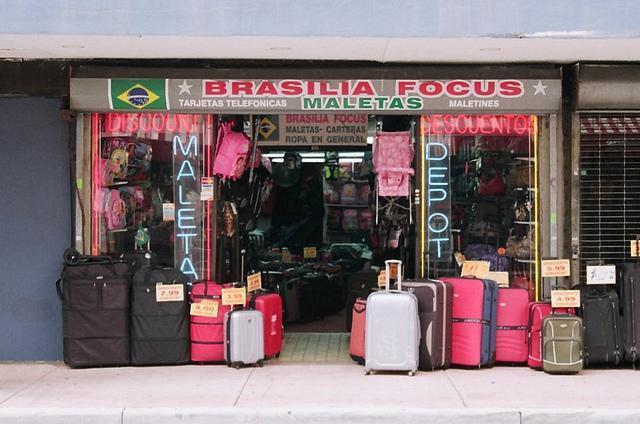How many suitcases are in the picture?
Give a very brief answer. 10. 